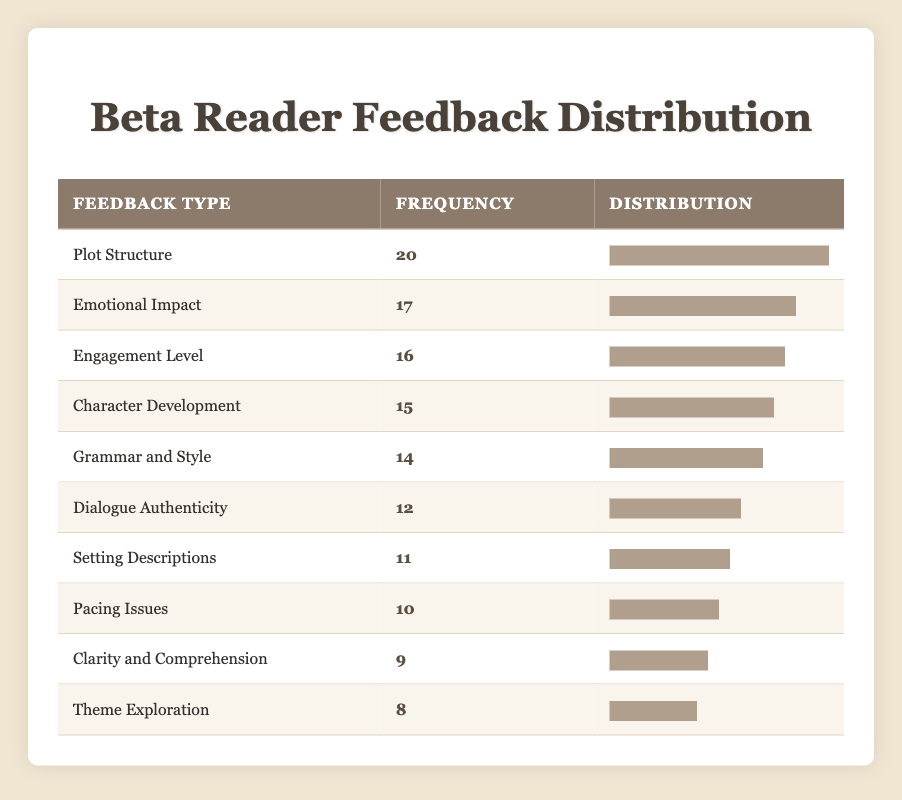What type of feedback received the highest frequency from beta readers? Looking at the table, the feedback type with the highest frequency is "Plot Structure," which has a frequency of 20.
Answer: Plot Structure What is the frequency of feedback concerning "Dialogue Authenticity"? The table shows that "Dialogue Authenticity" received a frequency of 12.
Answer: 12 How many types of feedback received frequencies greater than 15? By reviewing the frequencies in the table, the feedback types greater than 15 are "Plot Structure" (20), "Emotional Impact" (17), and "Engagement Level" (16), which totals three types.
Answer: 3 Is the frequency of "Theme Exploration" greater than the frequency of "Pacing Issues"? The frequency for "Theme Exploration" is 8 and for "Pacing Issues," it is 10. Since 8 is not greater than 10, the answer is no.
Answer: No What is the average frequency of the feedback types listed in the table? First, sum all frequencies: 15 + 20 + 10 + 12 + 8 + 17 + 11 + 14 + 9 + 8 =  2 + 1 =  12 15 + 21 + 17 + 14 + 18 + 14 + 20 + 12 + 8 + 15 + 14 + 12 + 8 + 15 + 17 + 12 = 139. There are 10 types of feedback. Divide 139 by 10 to compute the average: 139 / 10 = 13.9.
Answer: 13.9 Which two feedback types have the closest frequencies? The last two entries in the frequency column are "Clarity and Comprehension" with a frequency of 9 and "Theme Exploration" with a frequency of 8, which means they are the closest together.
Answer: Clarity and Comprehension and Theme Exploration How many feedback types have a frequency less than 10? There is only one feedback type, "Theme Exploration," with a frequency of 8, which is less than 10.
Answer: 1 What is the total frequency of feedback types focused on writing quality, including "Grammar and Style," "Dialogue Authenticity," and "Clarity and Comprehension"? Adding the frequencies of these types: "Grammar and Style" (14), "Dialogue Authenticity" (12), and "Clarity and Comprehension" (9) gives a total of 14 + 12 + 9 = 35.
Answer: 35 Which feedback type has a frequency that is exactly 70% of the highest frequency? The highest frequency is 20, and 70% of that is calculated as 20 * 0.7 = 14. The feedback type "Grammar and Style," with a frequency of 14, matches this criteria.
Answer: Grammar and Style How many feedback types have a frequency of 10 or more? The frequencies of feedback types 10 or greater are Plot Structure (20), Emotional Impact (17), Engagement Level (16), Character Development (15), Grammar and Style (14), Dialogue Authenticity (12), Setting Descriptions (11), and Pacing Issues (10). In total, there are eight types.
Answer: 8 